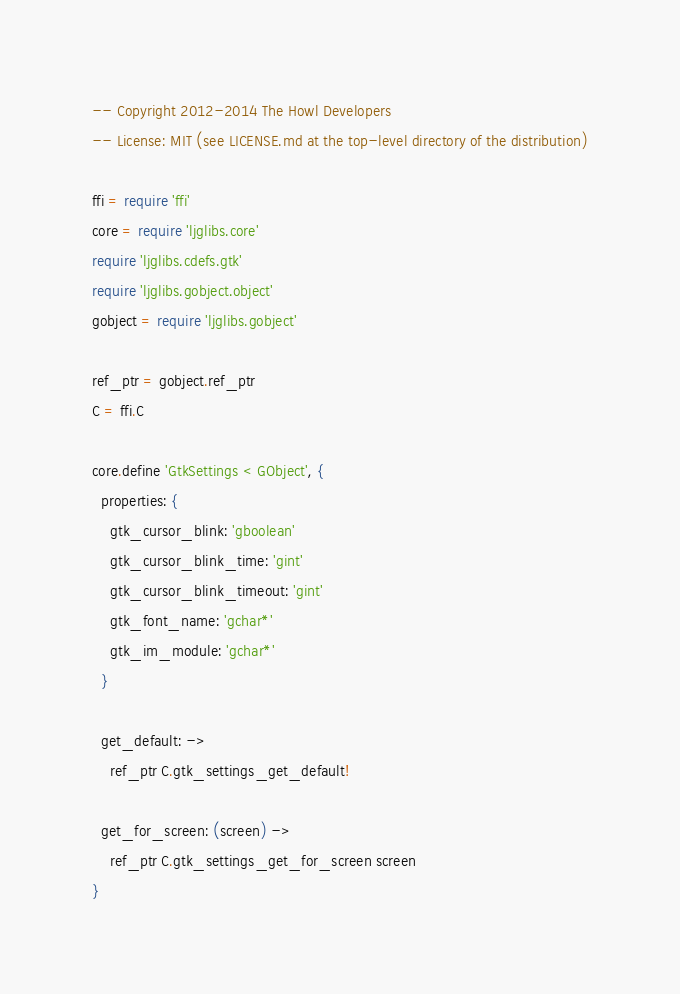Convert code to text. <code><loc_0><loc_0><loc_500><loc_500><_MoonScript_>-- Copyright 2012-2014 The Howl Developers
-- License: MIT (see LICENSE.md at the top-level directory of the distribution)

ffi = require 'ffi'
core = require 'ljglibs.core'
require 'ljglibs.cdefs.gtk'
require 'ljglibs.gobject.object'
gobject = require 'ljglibs.gobject'

ref_ptr = gobject.ref_ptr
C = ffi.C

core.define 'GtkSettings < GObject', {
  properties: {
    gtk_cursor_blink: 'gboolean'
    gtk_cursor_blink_time: 'gint'
    gtk_cursor_blink_timeout: 'gint'
    gtk_font_name: 'gchar*'
    gtk_im_module: 'gchar*'
  }

  get_default: ->
    ref_ptr C.gtk_settings_get_default!

  get_for_screen: (screen) ->
    ref_ptr C.gtk_settings_get_for_screen screen
}
</code> 